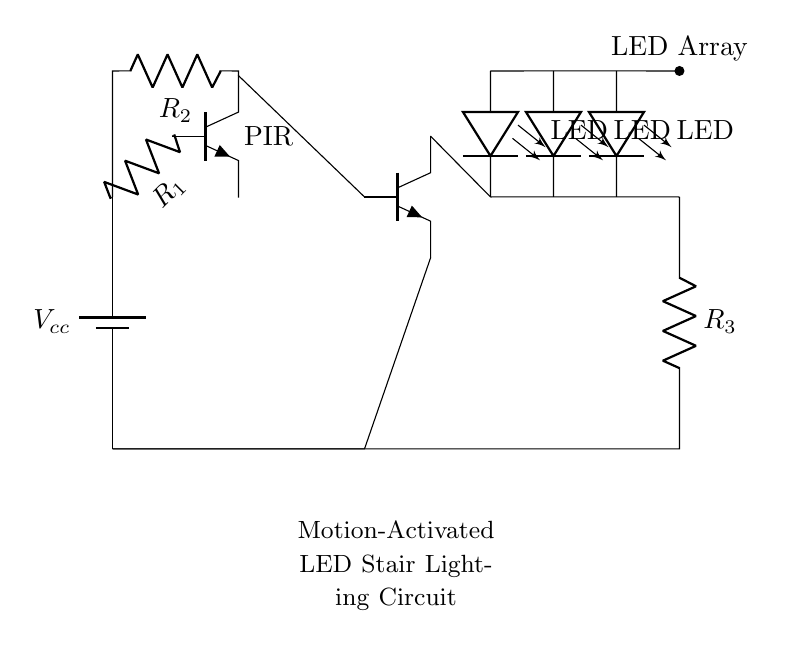What type of sensor is used in this circuit? The circuit uses a PIR sensor, which is indicated by the labelled symbol "PIR" in the diagram. PIR stands for Passive Infrared, commonly employed for motion detection.
Answer: PIR What are the resistance values of the resistors in the circuit? The circuit includes three resistors labelled as R1, R2, and R3. However, the exact resistance values are not specified in the circuit.
Answer: Not specified What happens to the LED array when motion is detected? When the PIR sensor detects motion, it activates the transistor which allows current to flow through the LED array, turning them on. This is inferred from the connection from the sensor to the transistor drive signal, which connects to the LED circuit.
Answer: LED array turns on Which component controls the power to the LED array? The transistor (Q2) acts as a switch in this circuit, controlling the flow of power to the LED array based on the signal it receives from the PIR sensor. When the sensor detects motion, it activates the transistor, allowing current to reach the LEDs.
Answer: Transistor What is the purpose of resistor R3 in the circuit? R3 is a current limiting resistor for the LED array. Its purpose is to ensure that the current flowing through the LEDs does not exceed their rated maximum, preventing damage and ensuring proper operation.
Answer: Current limiting How is the battery connected in this circuit? The battery is connected in parallel with the other components, providing the necessary voltage to the circuit. It is shown at the leftmost part, indicating it supplies power to the entire circuit structure.
Answer: In parallel 